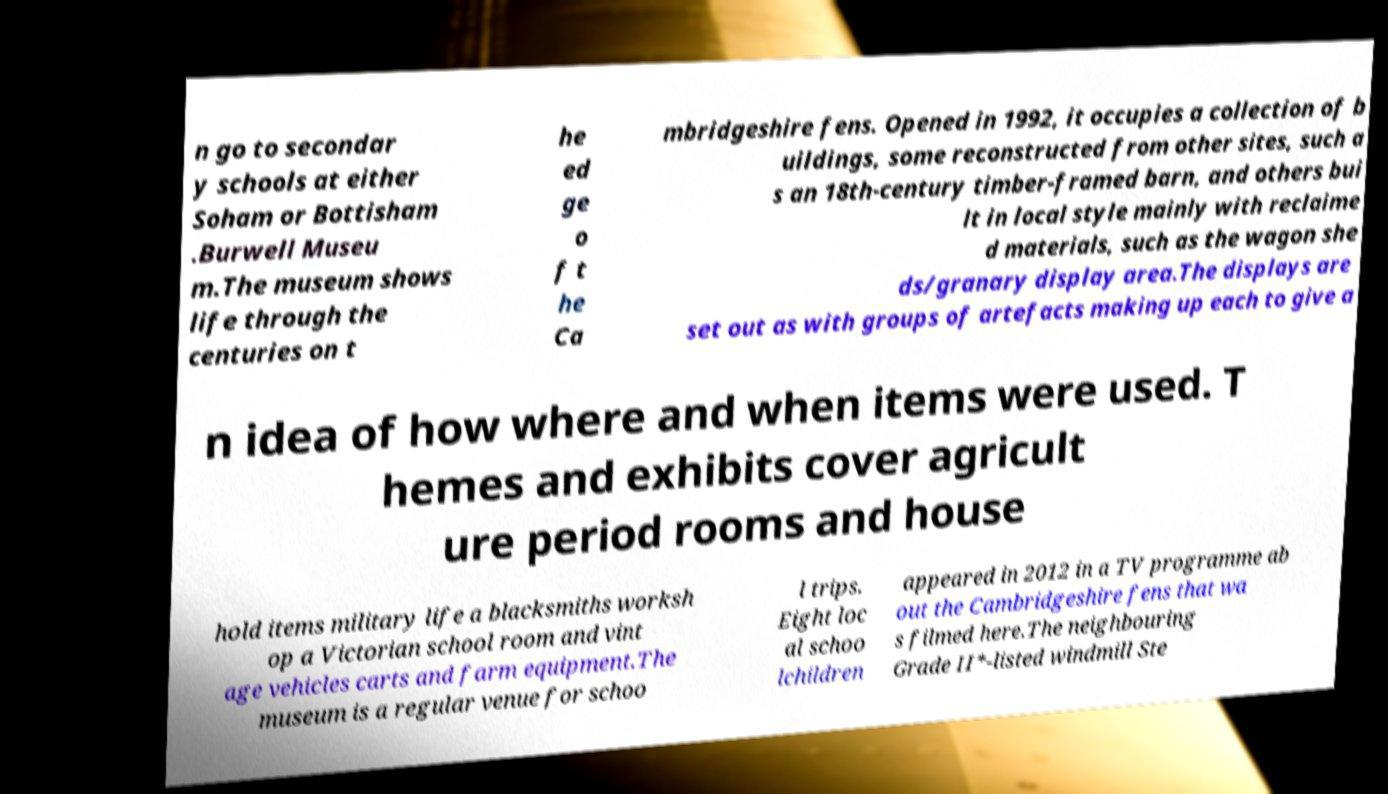What messages or text are displayed in this image? I need them in a readable, typed format. n go to secondar y schools at either Soham or Bottisham .Burwell Museu m.The museum shows life through the centuries on t he ed ge o f t he Ca mbridgeshire fens. Opened in 1992, it occupies a collection of b uildings, some reconstructed from other sites, such a s an 18th-century timber-framed barn, and others bui lt in local style mainly with reclaime d materials, such as the wagon she ds/granary display area.The displays are set out as with groups of artefacts making up each to give a n idea of how where and when items were used. T hemes and exhibits cover agricult ure period rooms and house hold items military life a blacksmiths worksh op a Victorian school room and vint age vehicles carts and farm equipment.The museum is a regular venue for schoo l trips. Eight loc al schoo lchildren appeared in 2012 in a TV programme ab out the Cambridgeshire fens that wa s filmed here.The neighbouring Grade II*-listed windmill Ste 